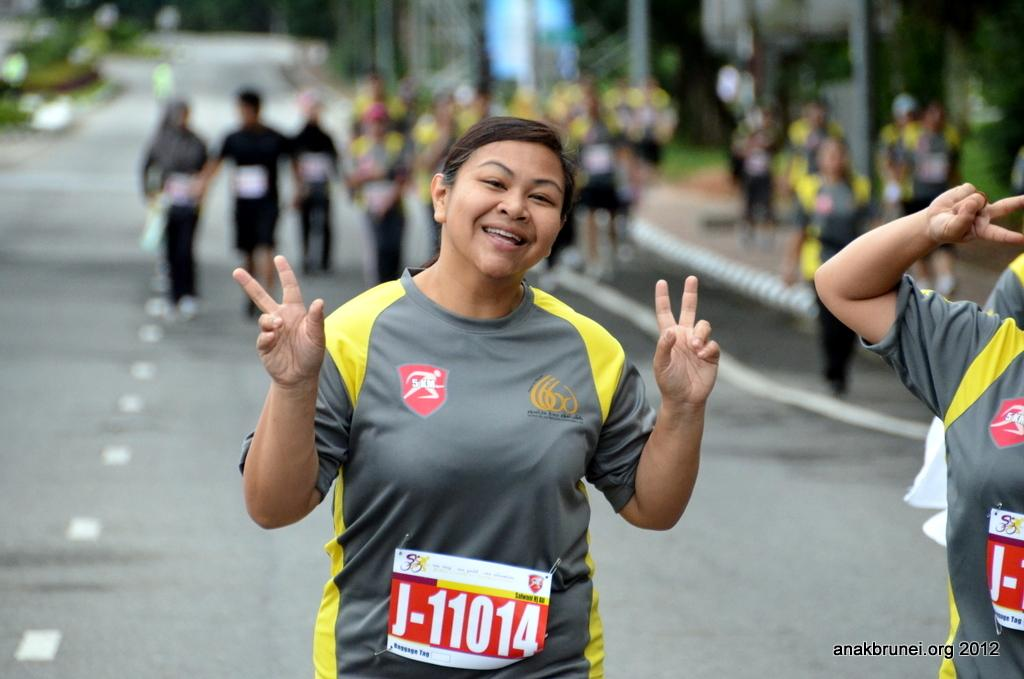Who is the main subject in the image? There is a lady in the image. What is the lady wearing that indicates her participation in an event? The lady is wearing a chest number. What is the lady's facial expression in the image? The lady is smiling. What can be seen in the background of the image? There is a road and many people in the background. How is the background of the image depicted? The background is blurred. What type of plant is being brushed by the hen in the image? There is no plant or hen present in the image. 